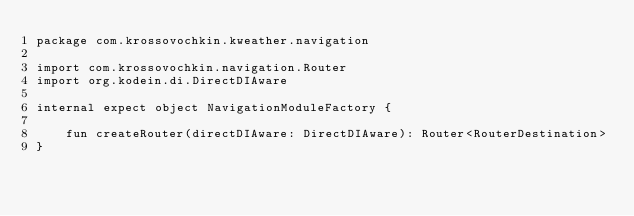Convert code to text. <code><loc_0><loc_0><loc_500><loc_500><_Kotlin_>package com.krossovochkin.kweather.navigation

import com.krossovochkin.navigation.Router
import org.kodein.di.DirectDIAware

internal expect object NavigationModuleFactory {

    fun createRouter(directDIAware: DirectDIAware): Router<RouterDestination>
}
</code> 